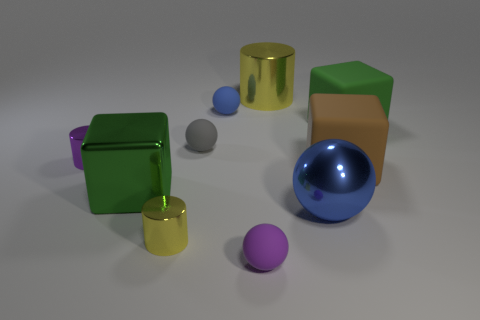Subtract all blocks. How many objects are left? 7 Add 2 small gray rubber objects. How many small gray rubber objects exist? 3 Subtract 0 brown cylinders. How many objects are left? 10 Subtract all large purple rubber cubes. Subtract all small purple cylinders. How many objects are left? 9 Add 9 brown blocks. How many brown blocks are left? 10 